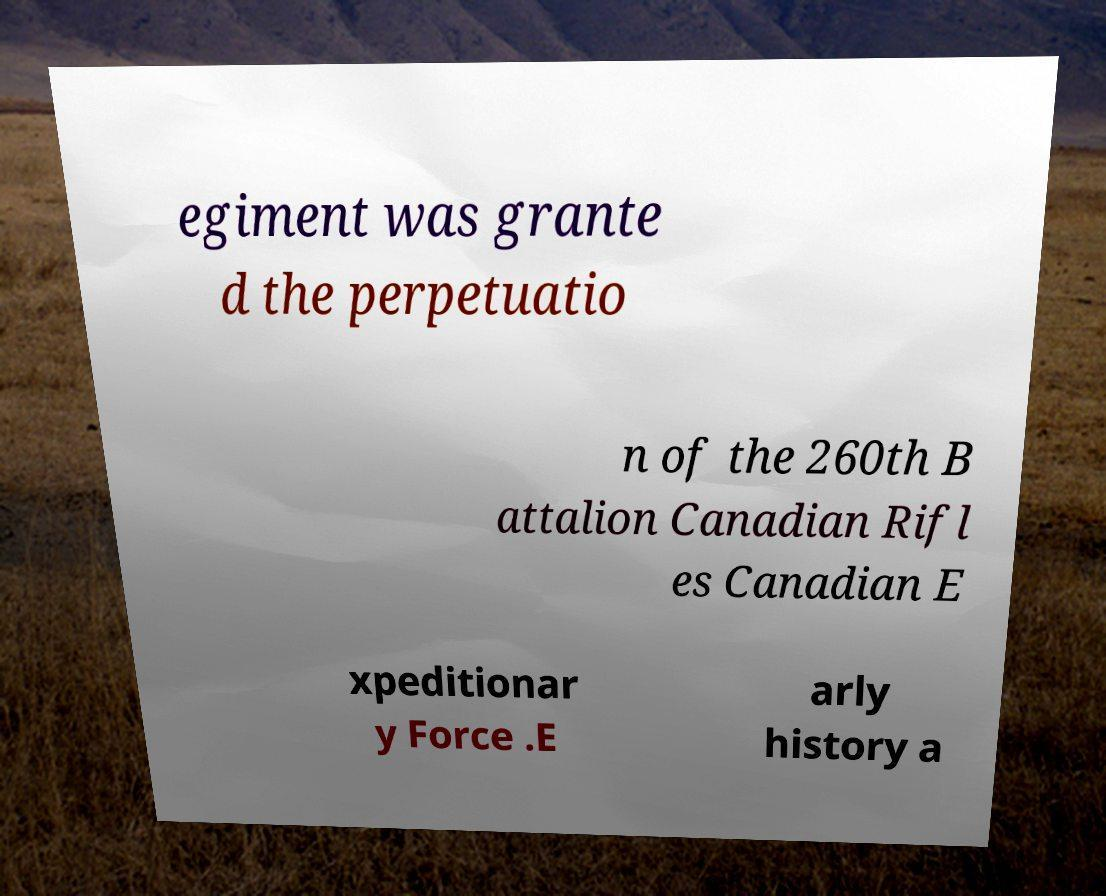Can you read and provide the text displayed in the image?This photo seems to have some interesting text. Can you extract and type it out for me? egiment was grante d the perpetuatio n of the 260th B attalion Canadian Rifl es Canadian E xpeditionar y Force .E arly history a 